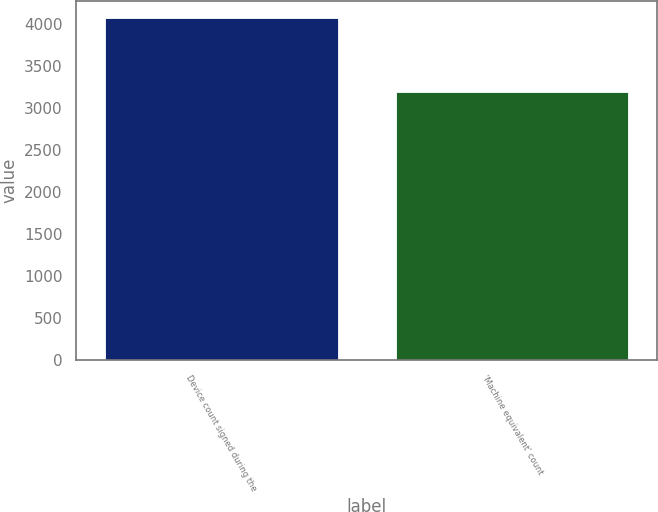<chart> <loc_0><loc_0><loc_500><loc_500><bar_chart><fcel>Device count signed during the<fcel>'Machine equivalent' count<nl><fcel>4072<fcel>3189<nl></chart> 